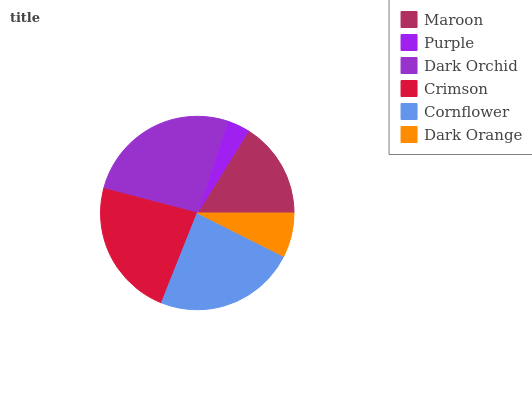Is Purple the minimum?
Answer yes or no. Yes. Is Dark Orchid the maximum?
Answer yes or no. Yes. Is Dark Orchid the minimum?
Answer yes or no. No. Is Purple the maximum?
Answer yes or no. No. Is Dark Orchid greater than Purple?
Answer yes or no. Yes. Is Purple less than Dark Orchid?
Answer yes or no. Yes. Is Purple greater than Dark Orchid?
Answer yes or no. No. Is Dark Orchid less than Purple?
Answer yes or no. No. Is Crimson the high median?
Answer yes or no. Yes. Is Maroon the low median?
Answer yes or no. Yes. Is Dark Orchid the high median?
Answer yes or no. No. Is Purple the low median?
Answer yes or no. No. 